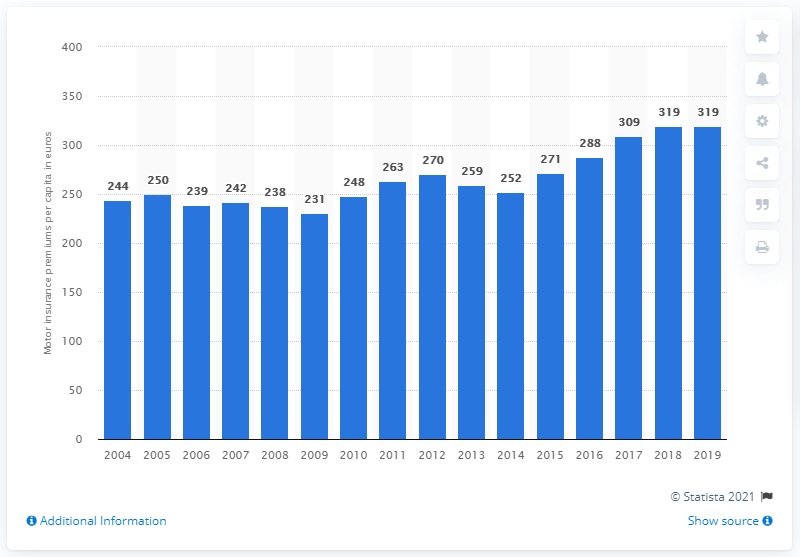In what year did the average premium per capita increase by 319 euros?
 2017 